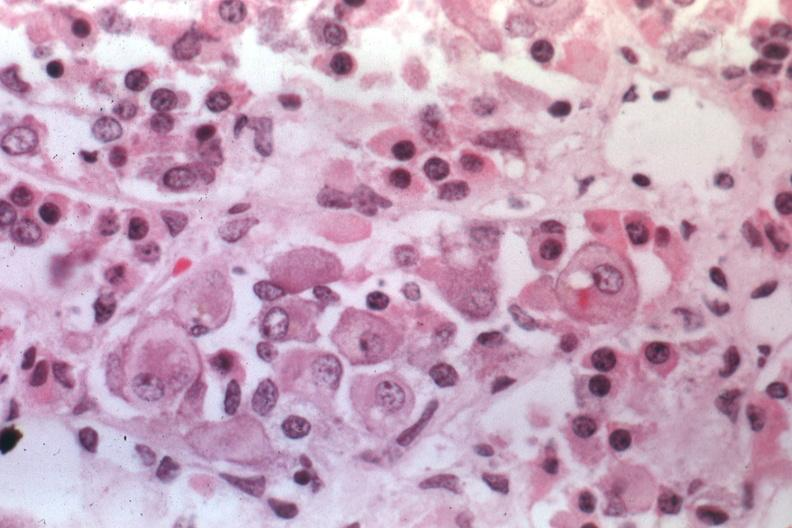s this image shows of smooth muscle cell with lipid in sarcoplasm and lipid present?
Answer the question using a single word or phrase. No 